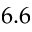<formula> <loc_0><loc_0><loc_500><loc_500>6 . 6</formula> 